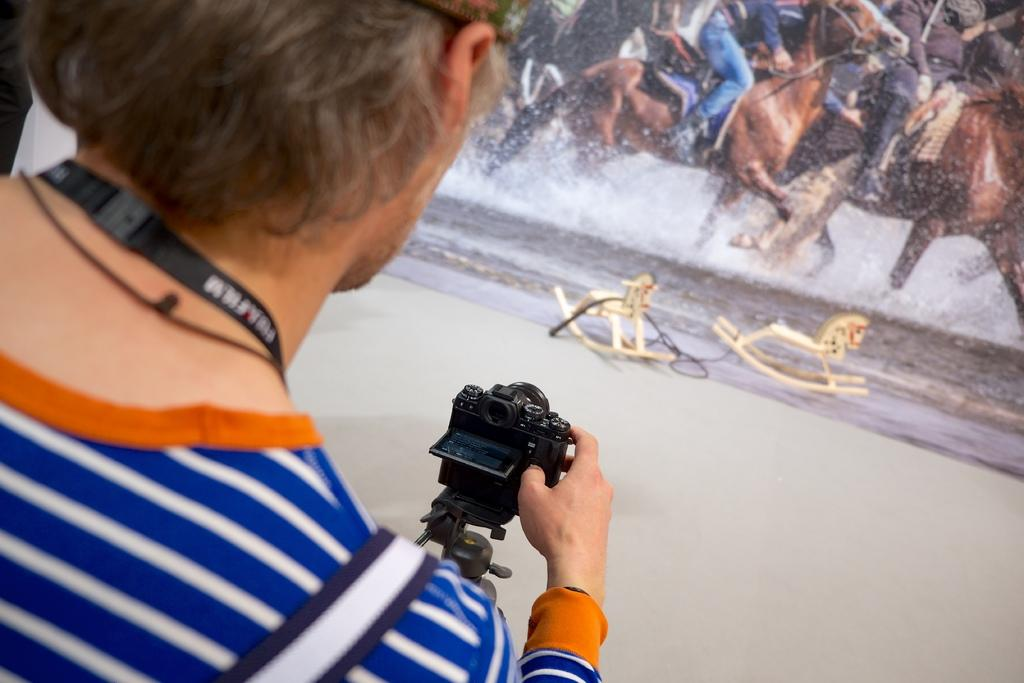What is the person in the image doing? The person is capturing a photo. What is the subject of the photo being taken? The photo is of a poster. What is depicted on the poster? The poster contains an image of horses. What is the horses' activity in the poster? The horses are running on the water surface in the poster. What type of cracker is the cat holding in the image? There is no cat or cracker present in the image. What song is being sung by the horses in the poster? The horses in the poster are not singing a song; they are running on the water surface. 